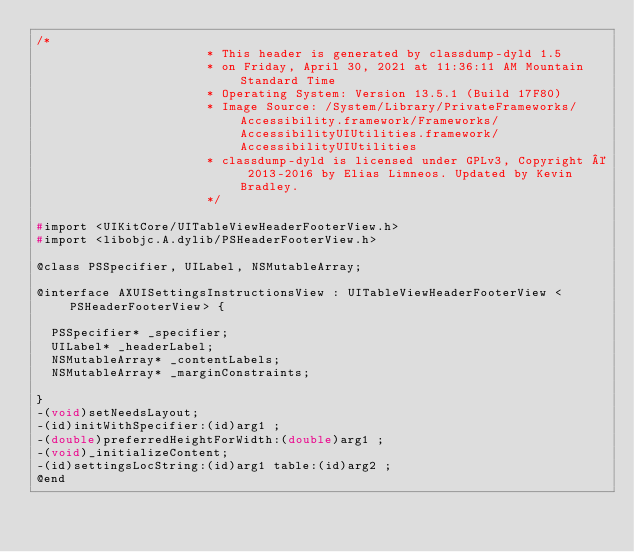<code> <loc_0><loc_0><loc_500><loc_500><_C_>/*
                       * This header is generated by classdump-dyld 1.5
                       * on Friday, April 30, 2021 at 11:36:11 AM Mountain Standard Time
                       * Operating System: Version 13.5.1 (Build 17F80)
                       * Image Source: /System/Library/PrivateFrameworks/Accessibility.framework/Frameworks/AccessibilityUIUtilities.framework/AccessibilityUIUtilities
                       * classdump-dyld is licensed under GPLv3, Copyright © 2013-2016 by Elias Limneos. Updated by Kevin Bradley.
                       */

#import <UIKitCore/UITableViewHeaderFooterView.h>
#import <libobjc.A.dylib/PSHeaderFooterView.h>

@class PSSpecifier, UILabel, NSMutableArray;

@interface AXUISettingsInstructionsView : UITableViewHeaderFooterView <PSHeaderFooterView> {

	PSSpecifier* _specifier;
	UILabel* _headerLabel;
	NSMutableArray* _contentLabels;
	NSMutableArray* _marginConstraints;

}
-(void)setNeedsLayout;
-(id)initWithSpecifier:(id)arg1 ;
-(double)preferredHeightForWidth:(double)arg1 ;
-(void)_initializeContent;
-(id)settingsLocString:(id)arg1 table:(id)arg2 ;
@end

</code> 